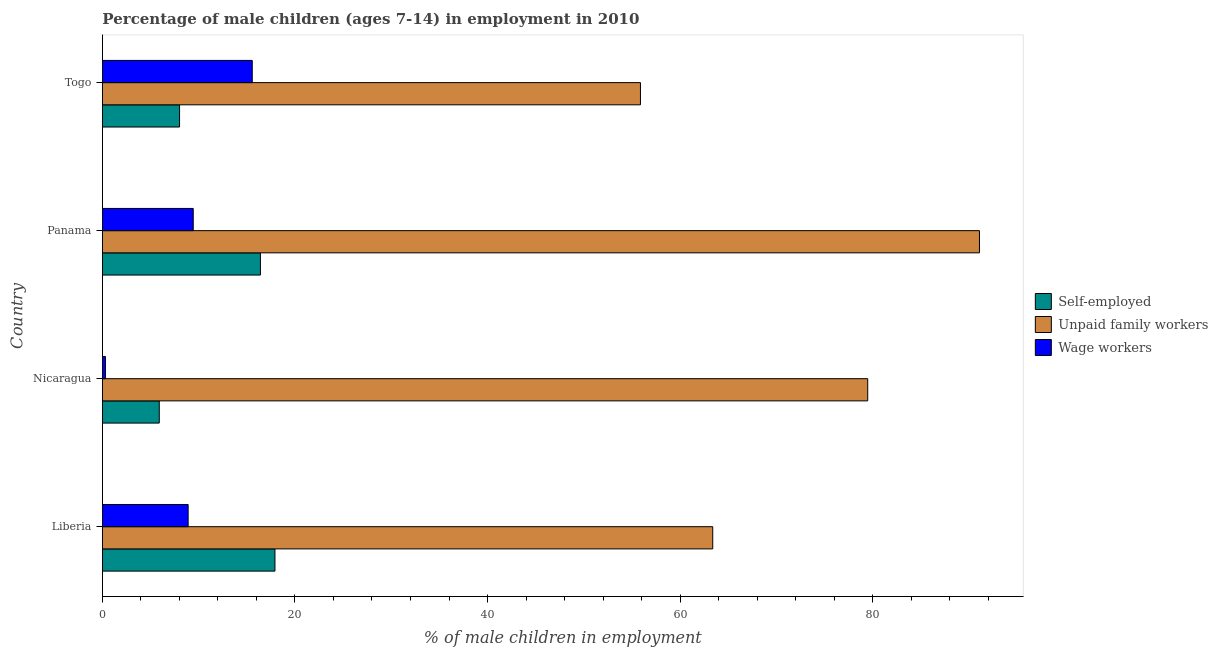How many different coloured bars are there?
Your answer should be very brief. 3. How many groups of bars are there?
Offer a very short reply. 4. Are the number of bars on each tick of the Y-axis equal?
Your response must be concise. Yes. What is the label of the 1st group of bars from the top?
Give a very brief answer. Togo. What is the percentage of children employed as unpaid family workers in Liberia?
Make the answer very short. 63.4. Across all countries, what is the maximum percentage of children employed as wage workers?
Offer a very short reply. 15.56. Across all countries, what is the minimum percentage of self employed children?
Offer a terse response. 5.9. In which country was the percentage of children employed as unpaid family workers maximum?
Offer a terse response. Panama. In which country was the percentage of children employed as unpaid family workers minimum?
Give a very brief answer. Togo. What is the total percentage of children employed as unpaid family workers in the graph?
Offer a very short reply. 289.9. What is the difference between the percentage of children employed as unpaid family workers in Liberia and that in Panama?
Your answer should be compact. -27.71. What is the difference between the percentage of children employed as unpaid family workers in Togo and the percentage of children employed as wage workers in Liberia?
Provide a succinct answer. 46.99. What is the average percentage of children employed as unpaid family workers per country?
Provide a short and direct response. 72.47. What is the difference between the percentage of children employed as wage workers and percentage of children employed as unpaid family workers in Liberia?
Give a very brief answer. -54.5. What is the ratio of the percentage of children employed as wage workers in Liberia to that in Togo?
Offer a terse response. 0.57. Is the percentage of children employed as unpaid family workers in Panama less than that in Togo?
Provide a succinct answer. No. Is the difference between the percentage of children employed as wage workers in Panama and Togo greater than the difference between the percentage of children employed as unpaid family workers in Panama and Togo?
Your answer should be compact. No. What is the difference between the highest and the second highest percentage of self employed children?
Provide a short and direct response. 1.51. What is the difference between the highest and the lowest percentage of self employed children?
Keep it short and to the point. 12.02. In how many countries, is the percentage of children employed as wage workers greater than the average percentage of children employed as wage workers taken over all countries?
Keep it short and to the point. 3. What does the 1st bar from the top in Togo represents?
Offer a terse response. Wage workers. What does the 3rd bar from the bottom in Panama represents?
Keep it short and to the point. Wage workers. What is the difference between two consecutive major ticks on the X-axis?
Ensure brevity in your answer.  20. Where does the legend appear in the graph?
Offer a very short reply. Center right. How many legend labels are there?
Keep it short and to the point. 3. What is the title of the graph?
Your response must be concise. Percentage of male children (ages 7-14) in employment in 2010. Does "Taxes on international trade" appear as one of the legend labels in the graph?
Provide a short and direct response. No. What is the label or title of the X-axis?
Give a very brief answer. % of male children in employment. What is the label or title of the Y-axis?
Provide a succinct answer. Country. What is the % of male children in employment of Self-employed in Liberia?
Offer a terse response. 17.92. What is the % of male children in employment of Unpaid family workers in Liberia?
Your answer should be compact. 63.4. What is the % of male children in employment in Self-employed in Nicaragua?
Ensure brevity in your answer.  5.9. What is the % of male children in employment of Unpaid family workers in Nicaragua?
Offer a terse response. 79.5. What is the % of male children in employment in Wage workers in Nicaragua?
Offer a terse response. 0.31. What is the % of male children in employment of Self-employed in Panama?
Provide a short and direct response. 16.41. What is the % of male children in employment in Unpaid family workers in Panama?
Keep it short and to the point. 91.11. What is the % of male children in employment in Wage workers in Panama?
Offer a very short reply. 9.43. What is the % of male children in employment of Self-employed in Togo?
Keep it short and to the point. 8.01. What is the % of male children in employment in Unpaid family workers in Togo?
Offer a terse response. 55.89. What is the % of male children in employment in Wage workers in Togo?
Your answer should be compact. 15.56. Across all countries, what is the maximum % of male children in employment in Self-employed?
Offer a very short reply. 17.92. Across all countries, what is the maximum % of male children in employment in Unpaid family workers?
Provide a short and direct response. 91.11. Across all countries, what is the maximum % of male children in employment of Wage workers?
Your answer should be very brief. 15.56. Across all countries, what is the minimum % of male children in employment of Unpaid family workers?
Provide a short and direct response. 55.89. Across all countries, what is the minimum % of male children in employment of Wage workers?
Your answer should be very brief. 0.31. What is the total % of male children in employment in Self-employed in the graph?
Keep it short and to the point. 48.24. What is the total % of male children in employment in Unpaid family workers in the graph?
Offer a very short reply. 289.9. What is the total % of male children in employment of Wage workers in the graph?
Keep it short and to the point. 34.2. What is the difference between the % of male children in employment in Self-employed in Liberia and that in Nicaragua?
Your answer should be compact. 12.02. What is the difference between the % of male children in employment of Unpaid family workers in Liberia and that in Nicaragua?
Provide a short and direct response. -16.1. What is the difference between the % of male children in employment in Wage workers in Liberia and that in Nicaragua?
Provide a succinct answer. 8.59. What is the difference between the % of male children in employment of Self-employed in Liberia and that in Panama?
Your answer should be very brief. 1.51. What is the difference between the % of male children in employment in Unpaid family workers in Liberia and that in Panama?
Provide a succinct answer. -27.71. What is the difference between the % of male children in employment in Wage workers in Liberia and that in Panama?
Keep it short and to the point. -0.53. What is the difference between the % of male children in employment in Self-employed in Liberia and that in Togo?
Ensure brevity in your answer.  9.91. What is the difference between the % of male children in employment in Unpaid family workers in Liberia and that in Togo?
Give a very brief answer. 7.51. What is the difference between the % of male children in employment in Wage workers in Liberia and that in Togo?
Offer a terse response. -6.66. What is the difference between the % of male children in employment of Self-employed in Nicaragua and that in Panama?
Give a very brief answer. -10.51. What is the difference between the % of male children in employment of Unpaid family workers in Nicaragua and that in Panama?
Offer a terse response. -11.61. What is the difference between the % of male children in employment of Wage workers in Nicaragua and that in Panama?
Provide a short and direct response. -9.12. What is the difference between the % of male children in employment of Self-employed in Nicaragua and that in Togo?
Ensure brevity in your answer.  -2.11. What is the difference between the % of male children in employment of Unpaid family workers in Nicaragua and that in Togo?
Provide a short and direct response. 23.61. What is the difference between the % of male children in employment in Wage workers in Nicaragua and that in Togo?
Make the answer very short. -15.25. What is the difference between the % of male children in employment in Unpaid family workers in Panama and that in Togo?
Give a very brief answer. 35.22. What is the difference between the % of male children in employment of Wage workers in Panama and that in Togo?
Your response must be concise. -6.13. What is the difference between the % of male children in employment of Self-employed in Liberia and the % of male children in employment of Unpaid family workers in Nicaragua?
Ensure brevity in your answer.  -61.58. What is the difference between the % of male children in employment in Self-employed in Liberia and the % of male children in employment in Wage workers in Nicaragua?
Make the answer very short. 17.61. What is the difference between the % of male children in employment in Unpaid family workers in Liberia and the % of male children in employment in Wage workers in Nicaragua?
Provide a succinct answer. 63.09. What is the difference between the % of male children in employment in Self-employed in Liberia and the % of male children in employment in Unpaid family workers in Panama?
Provide a short and direct response. -73.19. What is the difference between the % of male children in employment of Self-employed in Liberia and the % of male children in employment of Wage workers in Panama?
Your response must be concise. 8.49. What is the difference between the % of male children in employment of Unpaid family workers in Liberia and the % of male children in employment of Wage workers in Panama?
Your response must be concise. 53.97. What is the difference between the % of male children in employment in Self-employed in Liberia and the % of male children in employment in Unpaid family workers in Togo?
Offer a terse response. -37.97. What is the difference between the % of male children in employment of Self-employed in Liberia and the % of male children in employment of Wage workers in Togo?
Your answer should be compact. 2.36. What is the difference between the % of male children in employment in Unpaid family workers in Liberia and the % of male children in employment in Wage workers in Togo?
Your response must be concise. 47.84. What is the difference between the % of male children in employment in Self-employed in Nicaragua and the % of male children in employment in Unpaid family workers in Panama?
Offer a very short reply. -85.21. What is the difference between the % of male children in employment in Self-employed in Nicaragua and the % of male children in employment in Wage workers in Panama?
Offer a terse response. -3.53. What is the difference between the % of male children in employment of Unpaid family workers in Nicaragua and the % of male children in employment of Wage workers in Panama?
Provide a short and direct response. 70.07. What is the difference between the % of male children in employment of Self-employed in Nicaragua and the % of male children in employment of Unpaid family workers in Togo?
Provide a short and direct response. -49.99. What is the difference between the % of male children in employment in Self-employed in Nicaragua and the % of male children in employment in Wage workers in Togo?
Your response must be concise. -9.66. What is the difference between the % of male children in employment of Unpaid family workers in Nicaragua and the % of male children in employment of Wage workers in Togo?
Ensure brevity in your answer.  63.94. What is the difference between the % of male children in employment of Self-employed in Panama and the % of male children in employment of Unpaid family workers in Togo?
Provide a succinct answer. -39.48. What is the difference between the % of male children in employment of Self-employed in Panama and the % of male children in employment of Wage workers in Togo?
Your response must be concise. 0.85. What is the difference between the % of male children in employment in Unpaid family workers in Panama and the % of male children in employment in Wage workers in Togo?
Make the answer very short. 75.55. What is the average % of male children in employment in Self-employed per country?
Your answer should be compact. 12.06. What is the average % of male children in employment of Unpaid family workers per country?
Provide a short and direct response. 72.47. What is the average % of male children in employment in Wage workers per country?
Your answer should be compact. 8.55. What is the difference between the % of male children in employment of Self-employed and % of male children in employment of Unpaid family workers in Liberia?
Provide a succinct answer. -45.48. What is the difference between the % of male children in employment in Self-employed and % of male children in employment in Wage workers in Liberia?
Keep it short and to the point. 9.02. What is the difference between the % of male children in employment in Unpaid family workers and % of male children in employment in Wage workers in Liberia?
Keep it short and to the point. 54.5. What is the difference between the % of male children in employment in Self-employed and % of male children in employment in Unpaid family workers in Nicaragua?
Keep it short and to the point. -73.6. What is the difference between the % of male children in employment of Self-employed and % of male children in employment of Wage workers in Nicaragua?
Offer a terse response. 5.59. What is the difference between the % of male children in employment in Unpaid family workers and % of male children in employment in Wage workers in Nicaragua?
Offer a terse response. 79.19. What is the difference between the % of male children in employment of Self-employed and % of male children in employment of Unpaid family workers in Panama?
Your answer should be compact. -74.7. What is the difference between the % of male children in employment of Self-employed and % of male children in employment of Wage workers in Panama?
Ensure brevity in your answer.  6.98. What is the difference between the % of male children in employment in Unpaid family workers and % of male children in employment in Wage workers in Panama?
Provide a succinct answer. 81.68. What is the difference between the % of male children in employment in Self-employed and % of male children in employment in Unpaid family workers in Togo?
Offer a terse response. -47.88. What is the difference between the % of male children in employment of Self-employed and % of male children in employment of Wage workers in Togo?
Offer a terse response. -7.55. What is the difference between the % of male children in employment of Unpaid family workers and % of male children in employment of Wage workers in Togo?
Offer a terse response. 40.33. What is the ratio of the % of male children in employment in Self-employed in Liberia to that in Nicaragua?
Offer a very short reply. 3.04. What is the ratio of the % of male children in employment of Unpaid family workers in Liberia to that in Nicaragua?
Keep it short and to the point. 0.8. What is the ratio of the % of male children in employment of Wage workers in Liberia to that in Nicaragua?
Keep it short and to the point. 28.71. What is the ratio of the % of male children in employment in Self-employed in Liberia to that in Panama?
Make the answer very short. 1.09. What is the ratio of the % of male children in employment in Unpaid family workers in Liberia to that in Panama?
Offer a terse response. 0.7. What is the ratio of the % of male children in employment in Wage workers in Liberia to that in Panama?
Your response must be concise. 0.94. What is the ratio of the % of male children in employment in Self-employed in Liberia to that in Togo?
Provide a succinct answer. 2.24. What is the ratio of the % of male children in employment of Unpaid family workers in Liberia to that in Togo?
Give a very brief answer. 1.13. What is the ratio of the % of male children in employment in Wage workers in Liberia to that in Togo?
Provide a succinct answer. 0.57. What is the ratio of the % of male children in employment in Self-employed in Nicaragua to that in Panama?
Make the answer very short. 0.36. What is the ratio of the % of male children in employment of Unpaid family workers in Nicaragua to that in Panama?
Offer a very short reply. 0.87. What is the ratio of the % of male children in employment in Wage workers in Nicaragua to that in Panama?
Make the answer very short. 0.03. What is the ratio of the % of male children in employment of Self-employed in Nicaragua to that in Togo?
Keep it short and to the point. 0.74. What is the ratio of the % of male children in employment in Unpaid family workers in Nicaragua to that in Togo?
Give a very brief answer. 1.42. What is the ratio of the % of male children in employment in Wage workers in Nicaragua to that in Togo?
Provide a short and direct response. 0.02. What is the ratio of the % of male children in employment of Self-employed in Panama to that in Togo?
Your answer should be compact. 2.05. What is the ratio of the % of male children in employment in Unpaid family workers in Panama to that in Togo?
Your answer should be very brief. 1.63. What is the ratio of the % of male children in employment of Wage workers in Panama to that in Togo?
Keep it short and to the point. 0.61. What is the difference between the highest and the second highest % of male children in employment in Self-employed?
Make the answer very short. 1.51. What is the difference between the highest and the second highest % of male children in employment in Unpaid family workers?
Offer a very short reply. 11.61. What is the difference between the highest and the second highest % of male children in employment in Wage workers?
Offer a terse response. 6.13. What is the difference between the highest and the lowest % of male children in employment of Self-employed?
Provide a short and direct response. 12.02. What is the difference between the highest and the lowest % of male children in employment in Unpaid family workers?
Offer a very short reply. 35.22. What is the difference between the highest and the lowest % of male children in employment in Wage workers?
Your answer should be compact. 15.25. 